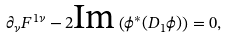<formula> <loc_0><loc_0><loc_500><loc_500>\partial _ { \nu } F ^ { 1 \nu } - 2 \text {Im} \left ( \phi ^ { * } ( D _ { 1 } \phi ) \right ) = 0 ,</formula> 